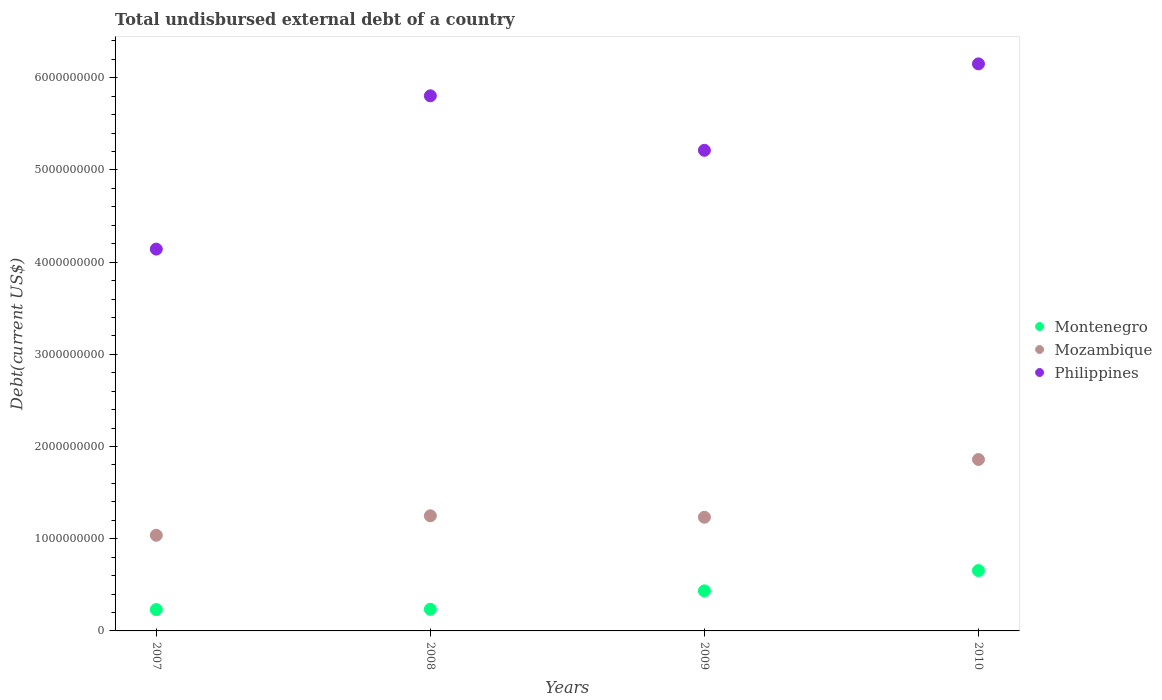What is the total undisbursed external debt in Mozambique in 2007?
Your response must be concise. 1.04e+09. Across all years, what is the maximum total undisbursed external debt in Philippines?
Ensure brevity in your answer.  6.15e+09. Across all years, what is the minimum total undisbursed external debt in Philippines?
Make the answer very short. 4.14e+09. In which year was the total undisbursed external debt in Montenegro maximum?
Offer a very short reply. 2010. What is the total total undisbursed external debt in Mozambique in the graph?
Your response must be concise. 5.38e+09. What is the difference between the total undisbursed external debt in Montenegro in 2007 and that in 2008?
Make the answer very short. -2.87e+06. What is the difference between the total undisbursed external debt in Montenegro in 2008 and the total undisbursed external debt in Mozambique in 2010?
Provide a succinct answer. -1.63e+09. What is the average total undisbursed external debt in Mozambique per year?
Your answer should be compact. 1.34e+09. In the year 2007, what is the difference between the total undisbursed external debt in Philippines and total undisbursed external debt in Mozambique?
Make the answer very short. 3.10e+09. What is the ratio of the total undisbursed external debt in Mozambique in 2007 to that in 2009?
Offer a very short reply. 0.84. Is the difference between the total undisbursed external debt in Philippines in 2007 and 2008 greater than the difference between the total undisbursed external debt in Mozambique in 2007 and 2008?
Keep it short and to the point. No. What is the difference between the highest and the second highest total undisbursed external debt in Montenegro?
Keep it short and to the point. 2.20e+08. What is the difference between the highest and the lowest total undisbursed external debt in Montenegro?
Provide a succinct answer. 4.23e+08. Are the values on the major ticks of Y-axis written in scientific E-notation?
Provide a short and direct response. No. What is the title of the graph?
Offer a terse response. Total undisbursed external debt of a country. Does "Bangladesh" appear as one of the legend labels in the graph?
Provide a succinct answer. No. What is the label or title of the Y-axis?
Offer a very short reply. Debt(current US$). What is the Debt(current US$) of Montenegro in 2007?
Provide a succinct answer. 2.31e+08. What is the Debt(current US$) of Mozambique in 2007?
Make the answer very short. 1.04e+09. What is the Debt(current US$) in Philippines in 2007?
Your answer should be compact. 4.14e+09. What is the Debt(current US$) in Montenegro in 2008?
Your answer should be compact. 2.34e+08. What is the Debt(current US$) of Mozambique in 2008?
Your response must be concise. 1.25e+09. What is the Debt(current US$) in Philippines in 2008?
Give a very brief answer. 5.80e+09. What is the Debt(current US$) in Montenegro in 2009?
Make the answer very short. 4.34e+08. What is the Debt(current US$) in Mozambique in 2009?
Ensure brevity in your answer.  1.23e+09. What is the Debt(current US$) in Philippines in 2009?
Keep it short and to the point. 5.21e+09. What is the Debt(current US$) of Montenegro in 2010?
Offer a terse response. 6.54e+08. What is the Debt(current US$) of Mozambique in 2010?
Your answer should be very brief. 1.86e+09. What is the Debt(current US$) of Philippines in 2010?
Ensure brevity in your answer.  6.15e+09. Across all years, what is the maximum Debt(current US$) in Montenegro?
Ensure brevity in your answer.  6.54e+08. Across all years, what is the maximum Debt(current US$) in Mozambique?
Ensure brevity in your answer.  1.86e+09. Across all years, what is the maximum Debt(current US$) of Philippines?
Provide a short and direct response. 6.15e+09. Across all years, what is the minimum Debt(current US$) in Montenegro?
Ensure brevity in your answer.  2.31e+08. Across all years, what is the minimum Debt(current US$) of Mozambique?
Offer a terse response. 1.04e+09. Across all years, what is the minimum Debt(current US$) in Philippines?
Ensure brevity in your answer.  4.14e+09. What is the total Debt(current US$) in Montenegro in the graph?
Offer a very short reply. 1.55e+09. What is the total Debt(current US$) of Mozambique in the graph?
Keep it short and to the point. 5.38e+09. What is the total Debt(current US$) in Philippines in the graph?
Give a very brief answer. 2.13e+1. What is the difference between the Debt(current US$) in Montenegro in 2007 and that in 2008?
Ensure brevity in your answer.  -2.87e+06. What is the difference between the Debt(current US$) of Mozambique in 2007 and that in 2008?
Your response must be concise. -2.11e+08. What is the difference between the Debt(current US$) in Philippines in 2007 and that in 2008?
Your response must be concise. -1.66e+09. What is the difference between the Debt(current US$) in Montenegro in 2007 and that in 2009?
Offer a very short reply. -2.03e+08. What is the difference between the Debt(current US$) of Mozambique in 2007 and that in 2009?
Keep it short and to the point. -1.95e+08. What is the difference between the Debt(current US$) of Philippines in 2007 and that in 2009?
Ensure brevity in your answer.  -1.07e+09. What is the difference between the Debt(current US$) of Montenegro in 2007 and that in 2010?
Your answer should be compact. -4.23e+08. What is the difference between the Debt(current US$) in Mozambique in 2007 and that in 2010?
Provide a short and direct response. -8.22e+08. What is the difference between the Debt(current US$) in Philippines in 2007 and that in 2010?
Offer a very short reply. -2.01e+09. What is the difference between the Debt(current US$) in Montenegro in 2008 and that in 2009?
Your answer should be compact. -2.00e+08. What is the difference between the Debt(current US$) in Mozambique in 2008 and that in 2009?
Give a very brief answer. 1.57e+07. What is the difference between the Debt(current US$) of Philippines in 2008 and that in 2009?
Ensure brevity in your answer.  5.91e+08. What is the difference between the Debt(current US$) of Montenegro in 2008 and that in 2010?
Keep it short and to the point. -4.20e+08. What is the difference between the Debt(current US$) of Mozambique in 2008 and that in 2010?
Your response must be concise. -6.11e+08. What is the difference between the Debt(current US$) in Philippines in 2008 and that in 2010?
Your answer should be very brief. -3.46e+08. What is the difference between the Debt(current US$) of Montenegro in 2009 and that in 2010?
Offer a terse response. -2.20e+08. What is the difference between the Debt(current US$) in Mozambique in 2009 and that in 2010?
Provide a succinct answer. -6.27e+08. What is the difference between the Debt(current US$) in Philippines in 2009 and that in 2010?
Offer a very short reply. -9.38e+08. What is the difference between the Debt(current US$) of Montenegro in 2007 and the Debt(current US$) of Mozambique in 2008?
Provide a succinct answer. -1.02e+09. What is the difference between the Debt(current US$) in Montenegro in 2007 and the Debt(current US$) in Philippines in 2008?
Give a very brief answer. -5.57e+09. What is the difference between the Debt(current US$) of Mozambique in 2007 and the Debt(current US$) of Philippines in 2008?
Ensure brevity in your answer.  -4.77e+09. What is the difference between the Debt(current US$) of Montenegro in 2007 and the Debt(current US$) of Mozambique in 2009?
Provide a succinct answer. -1.00e+09. What is the difference between the Debt(current US$) of Montenegro in 2007 and the Debt(current US$) of Philippines in 2009?
Offer a very short reply. -4.98e+09. What is the difference between the Debt(current US$) of Mozambique in 2007 and the Debt(current US$) of Philippines in 2009?
Keep it short and to the point. -4.18e+09. What is the difference between the Debt(current US$) of Montenegro in 2007 and the Debt(current US$) of Mozambique in 2010?
Make the answer very short. -1.63e+09. What is the difference between the Debt(current US$) of Montenegro in 2007 and the Debt(current US$) of Philippines in 2010?
Ensure brevity in your answer.  -5.92e+09. What is the difference between the Debt(current US$) of Mozambique in 2007 and the Debt(current US$) of Philippines in 2010?
Your answer should be very brief. -5.11e+09. What is the difference between the Debt(current US$) of Montenegro in 2008 and the Debt(current US$) of Mozambique in 2009?
Give a very brief answer. -9.99e+08. What is the difference between the Debt(current US$) in Montenegro in 2008 and the Debt(current US$) in Philippines in 2009?
Offer a terse response. -4.98e+09. What is the difference between the Debt(current US$) of Mozambique in 2008 and the Debt(current US$) of Philippines in 2009?
Ensure brevity in your answer.  -3.96e+09. What is the difference between the Debt(current US$) of Montenegro in 2008 and the Debt(current US$) of Mozambique in 2010?
Make the answer very short. -1.63e+09. What is the difference between the Debt(current US$) of Montenegro in 2008 and the Debt(current US$) of Philippines in 2010?
Give a very brief answer. -5.92e+09. What is the difference between the Debt(current US$) in Mozambique in 2008 and the Debt(current US$) in Philippines in 2010?
Keep it short and to the point. -4.90e+09. What is the difference between the Debt(current US$) in Montenegro in 2009 and the Debt(current US$) in Mozambique in 2010?
Provide a short and direct response. -1.43e+09. What is the difference between the Debt(current US$) of Montenegro in 2009 and the Debt(current US$) of Philippines in 2010?
Your answer should be compact. -5.72e+09. What is the difference between the Debt(current US$) of Mozambique in 2009 and the Debt(current US$) of Philippines in 2010?
Give a very brief answer. -4.92e+09. What is the average Debt(current US$) in Montenegro per year?
Your response must be concise. 3.89e+08. What is the average Debt(current US$) of Mozambique per year?
Ensure brevity in your answer.  1.34e+09. What is the average Debt(current US$) of Philippines per year?
Provide a short and direct response. 5.33e+09. In the year 2007, what is the difference between the Debt(current US$) in Montenegro and Debt(current US$) in Mozambique?
Provide a succinct answer. -8.06e+08. In the year 2007, what is the difference between the Debt(current US$) of Montenegro and Debt(current US$) of Philippines?
Offer a very short reply. -3.91e+09. In the year 2007, what is the difference between the Debt(current US$) of Mozambique and Debt(current US$) of Philippines?
Your answer should be compact. -3.10e+09. In the year 2008, what is the difference between the Debt(current US$) in Montenegro and Debt(current US$) in Mozambique?
Keep it short and to the point. -1.01e+09. In the year 2008, what is the difference between the Debt(current US$) in Montenegro and Debt(current US$) in Philippines?
Give a very brief answer. -5.57e+09. In the year 2008, what is the difference between the Debt(current US$) in Mozambique and Debt(current US$) in Philippines?
Make the answer very short. -4.56e+09. In the year 2009, what is the difference between the Debt(current US$) of Montenegro and Debt(current US$) of Mozambique?
Offer a very short reply. -7.99e+08. In the year 2009, what is the difference between the Debt(current US$) of Montenegro and Debt(current US$) of Philippines?
Your answer should be very brief. -4.78e+09. In the year 2009, what is the difference between the Debt(current US$) in Mozambique and Debt(current US$) in Philippines?
Ensure brevity in your answer.  -3.98e+09. In the year 2010, what is the difference between the Debt(current US$) in Montenegro and Debt(current US$) in Mozambique?
Give a very brief answer. -1.21e+09. In the year 2010, what is the difference between the Debt(current US$) in Montenegro and Debt(current US$) in Philippines?
Ensure brevity in your answer.  -5.50e+09. In the year 2010, what is the difference between the Debt(current US$) of Mozambique and Debt(current US$) of Philippines?
Ensure brevity in your answer.  -4.29e+09. What is the ratio of the Debt(current US$) of Montenegro in 2007 to that in 2008?
Ensure brevity in your answer.  0.99. What is the ratio of the Debt(current US$) in Mozambique in 2007 to that in 2008?
Offer a terse response. 0.83. What is the ratio of the Debt(current US$) in Philippines in 2007 to that in 2008?
Ensure brevity in your answer.  0.71. What is the ratio of the Debt(current US$) of Montenegro in 2007 to that in 2009?
Offer a terse response. 0.53. What is the ratio of the Debt(current US$) of Mozambique in 2007 to that in 2009?
Your answer should be very brief. 0.84. What is the ratio of the Debt(current US$) of Philippines in 2007 to that in 2009?
Your response must be concise. 0.79. What is the ratio of the Debt(current US$) in Montenegro in 2007 to that in 2010?
Give a very brief answer. 0.35. What is the ratio of the Debt(current US$) in Mozambique in 2007 to that in 2010?
Your response must be concise. 0.56. What is the ratio of the Debt(current US$) of Philippines in 2007 to that in 2010?
Your answer should be very brief. 0.67. What is the ratio of the Debt(current US$) of Montenegro in 2008 to that in 2009?
Provide a succinct answer. 0.54. What is the ratio of the Debt(current US$) in Mozambique in 2008 to that in 2009?
Your answer should be very brief. 1.01. What is the ratio of the Debt(current US$) of Philippines in 2008 to that in 2009?
Offer a terse response. 1.11. What is the ratio of the Debt(current US$) of Montenegro in 2008 to that in 2010?
Offer a terse response. 0.36. What is the ratio of the Debt(current US$) of Mozambique in 2008 to that in 2010?
Offer a very short reply. 0.67. What is the ratio of the Debt(current US$) of Philippines in 2008 to that in 2010?
Your answer should be compact. 0.94. What is the ratio of the Debt(current US$) in Montenegro in 2009 to that in 2010?
Make the answer very short. 0.66. What is the ratio of the Debt(current US$) in Mozambique in 2009 to that in 2010?
Offer a terse response. 0.66. What is the ratio of the Debt(current US$) in Philippines in 2009 to that in 2010?
Offer a very short reply. 0.85. What is the difference between the highest and the second highest Debt(current US$) of Montenegro?
Provide a short and direct response. 2.20e+08. What is the difference between the highest and the second highest Debt(current US$) in Mozambique?
Your answer should be very brief. 6.11e+08. What is the difference between the highest and the second highest Debt(current US$) in Philippines?
Provide a succinct answer. 3.46e+08. What is the difference between the highest and the lowest Debt(current US$) in Montenegro?
Give a very brief answer. 4.23e+08. What is the difference between the highest and the lowest Debt(current US$) in Mozambique?
Give a very brief answer. 8.22e+08. What is the difference between the highest and the lowest Debt(current US$) in Philippines?
Provide a succinct answer. 2.01e+09. 